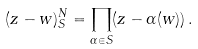Convert formula to latex. <formula><loc_0><loc_0><loc_500><loc_500>( z - w ) ^ { N } _ { S } = \prod _ { \alpha \in S } ( z - \alpha ( w ) ) \, .</formula> 